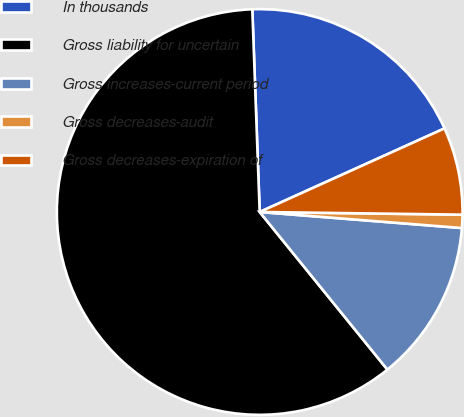Convert chart. <chart><loc_0><loc_0><loc_500><loc_500><pie_chart><fcel>In thousands<fcel>Gross liability for uncertain<fcel>Gross increases-current period<fcel>Gross decreases-audit<fcel>Gross decreases-expiration of<nl><fcel>18.82%<fcel>60.26%<fcel>12.9%<fcel>1.05%<fcel>6.97%<nl></chart> 